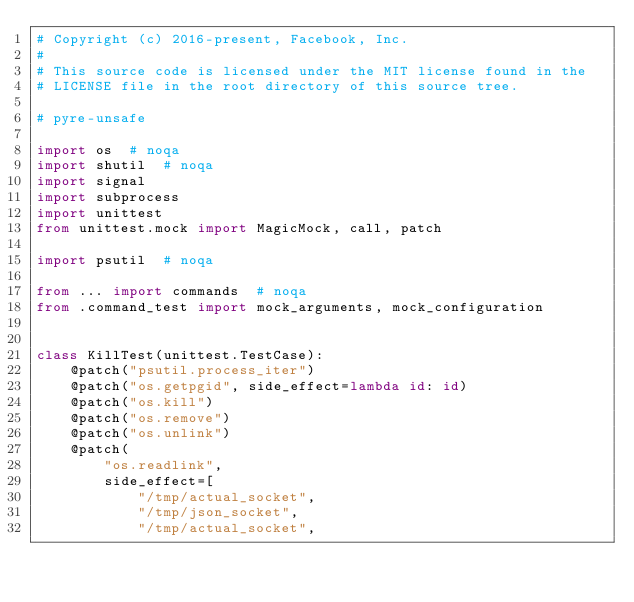Convert code to text. <code><loc_0><loc_0><loc_500><loc_500><_Python_># Copyright (c) 2016-present, Facebook, Inc.
#
# This source code is licensed under the MIT license found in the
# LICENSE file in the root directory of this source tree.

# pyre-unsafe

import os  # noqa
import shutil  # noqa
import signal
import subprocess
import unittest
from unittest.mock import MagicMock, call, patch

import psutil  # noqa

from ... import commands  # noqa
from .command_test import mock_arguments, mock_configuration


class KillTest(unittest.TestCase):
    @patch("psutil.process_iter")
    @patch("os.getpgid", side_effect=lambda id: id)
    @patch("os.kill")
    @patch("os.remove")
    @patch("os.unlink")
    @patch(
        "os.readlink",
        side_effect=[
            "/tmp/actual_socket",
            "/tmp/json_socket",
            "/tmp/actual_socket",</code> 